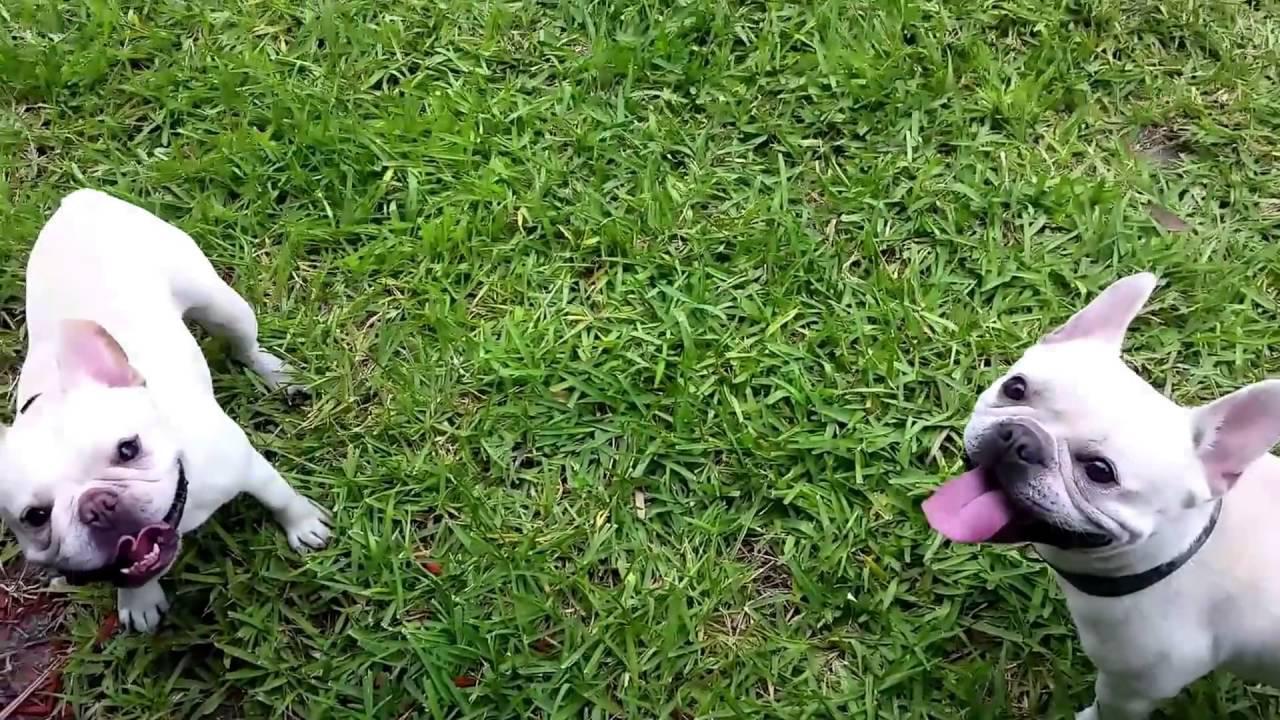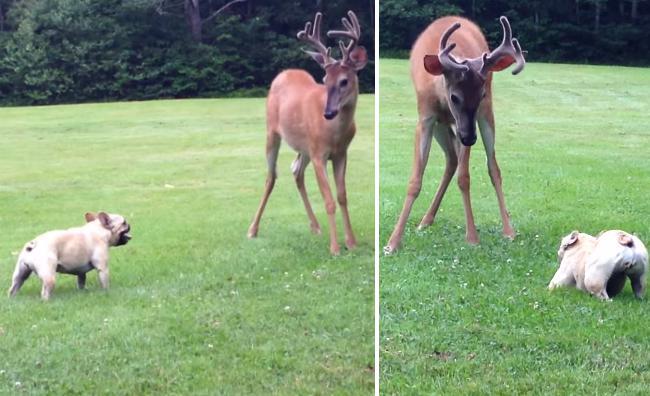The first image is the image on the left, the second image is the image on the right. Examine the images to the left and right. Is the description "Each picture includes more than one mammal." accurate? Answer yes or no. Yes. The first image is the image on the left, the second image is the image on the right. Assess this claim about the two images: "A total of one French Bulldog has something in its mouth.". Correct or not? Answer yes or no. No. 